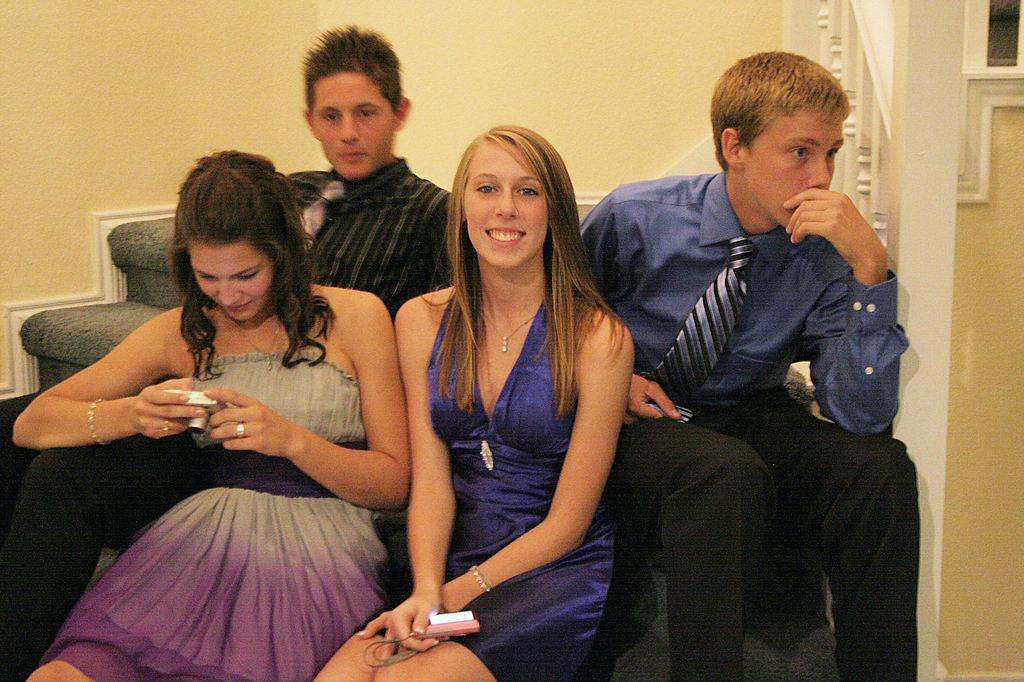How many people are in the image? There are four people in the image, two women and two men. What are the people doing in the image? The people are sitting on a sofa. What can be seen in the background of the image? There is a wall in the background of the image. What theory is being discussed by the spiders in the image? There are no spiders present in the image, and therefore no discussion of any theory can be observed. 